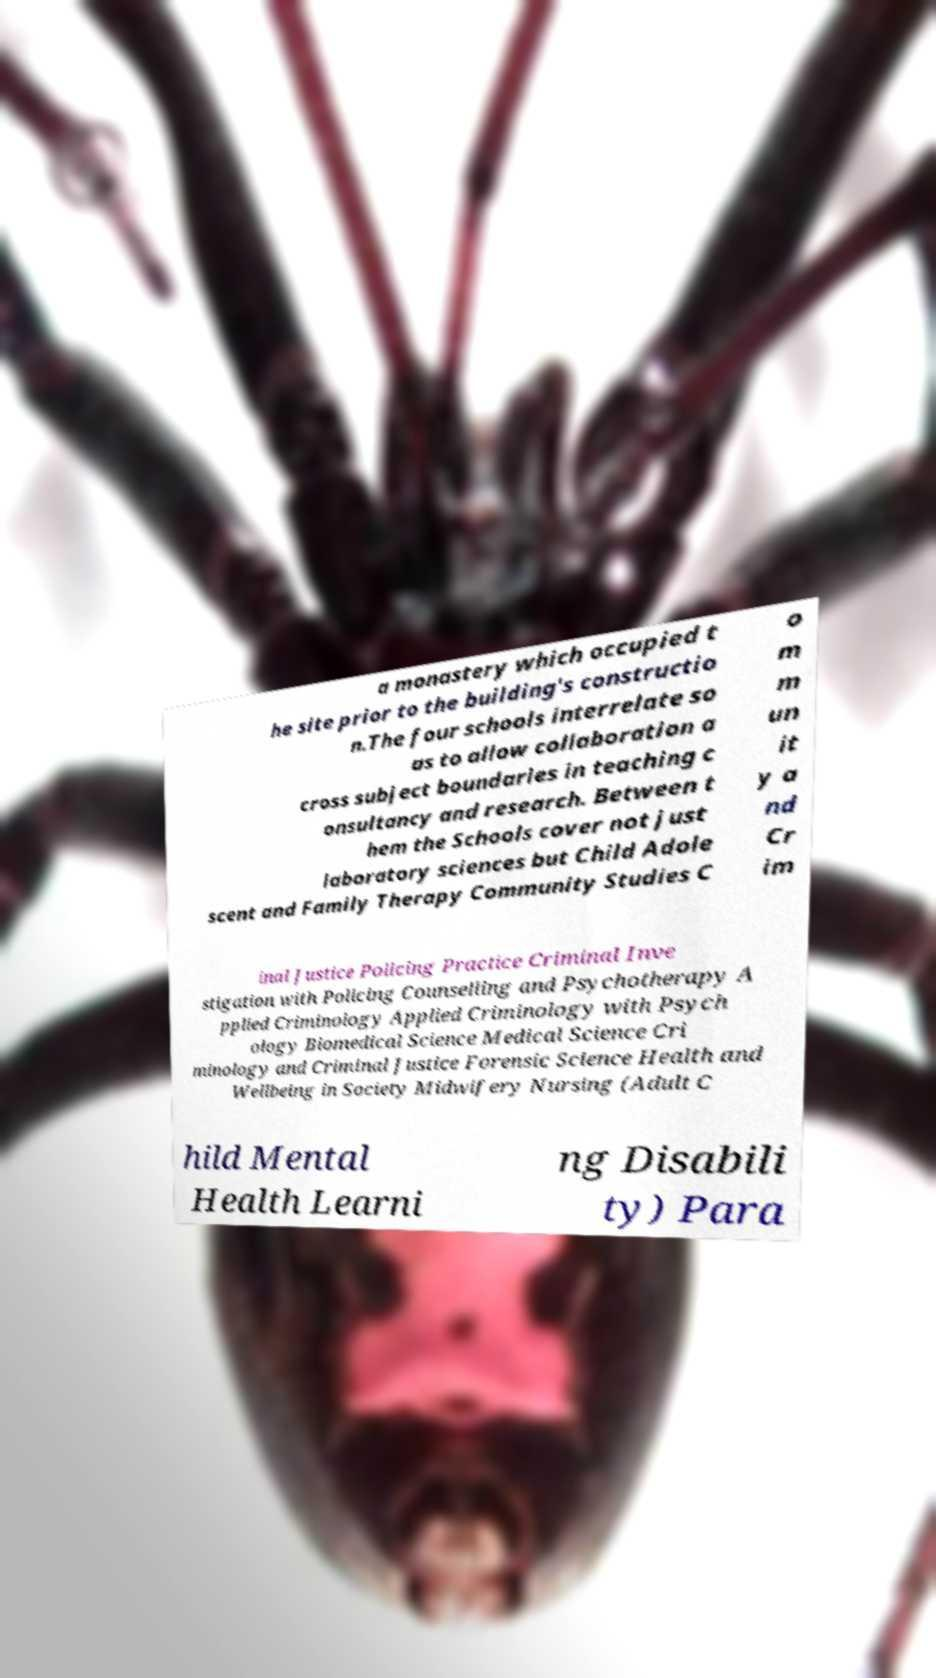Could you extract and type out the text from this image? a monastery which occupied t he site prior to the building's constructio n.The four schools interrelate so as to allow collaboration a cross subject boundaries in teaching c onsultancy and research. Between t hem the Schools cover not just laboratory sciences but Child Adole scent and Family Therapy Community Studies C o m m un it y a nd Cr im inal Justice Policing Practice Criminal Inve stigation with Policing Counselling and Psychotherapy A pplied Criminology Applied Criminology with Psych ology Biomedical Science Medical Science Cri minology and Criminal Justice Forensic Science Health and Wellbeing in Society Midwifery Nursing (Adult C hild Mental Health Learni ng Disabili ty) Para 